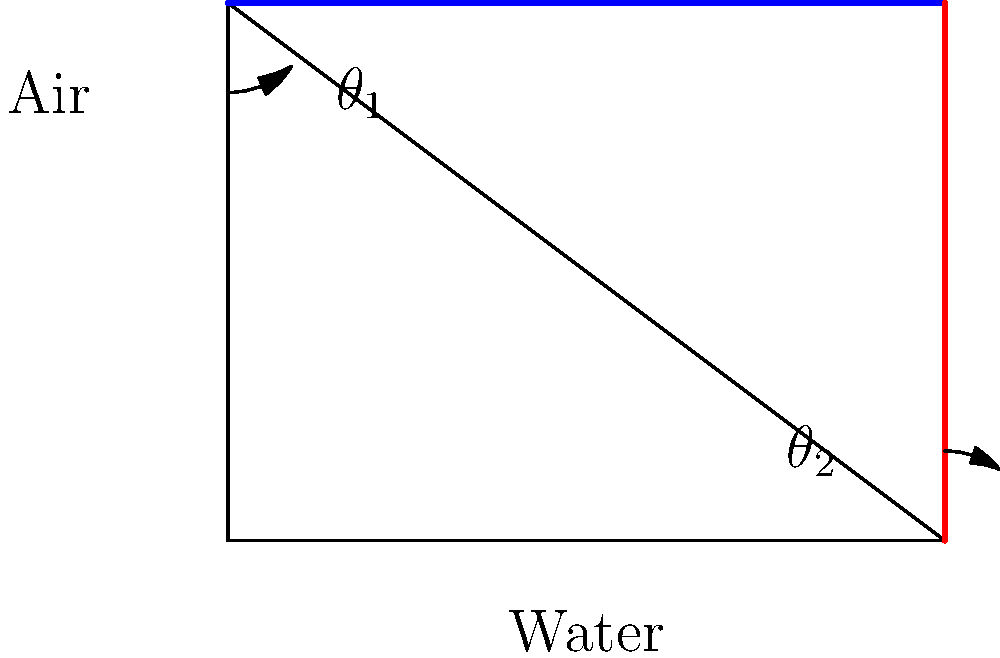In your latest novel, you've described a scene where a beam of light passes from air into water. The incident angle in air is 45°, and the speed of light in water is approximately 0.75 times its speed in air. Using Snell's law, what is the angle of refraction in water? How does this phenomenon relate to the literary concept of perspective shifting? Let's approach this step-by-step, drawing parallels to narrative perspective:

1) Snell's law states: $n_1 \sin \theta_1 = n_2 \sin \theta_2$, where $n$ is the refractive index and $\theta$ is the angle.

2) We know that $n = \frac{c}{v}$, where $c$ is the speed of light in vacuum and $v$ is the speed in the medium.

3) For air, $n_1 \approx 1$ (approximating air as vacuum).
   For water, $n_2 = \frac{1}{0.75} = \frac{4}{3}$ (since $v_{water} = 0.75c$).

4) We're given $\theta_1 = 45°$. Let's substitute into Snell's law:

   $1 \cdot \sin 45° = \frac{4}{3} \sin \theta_2$

5) Simplify: $\frac{\sqrt{2}}{2} = \frac{4}{3} \sin \theta_2$

6) Solve for $\theta_2$:
   $\sin \theta_2 = \frac{3\sqrt{2}}{8}$
   $\theta_2 = \arcsin(\frac{3\sqrt{2}}{8}) \approx 32.0°$

This refraction is analogous to how a shift in narrative perspective can alter the reader's perception of events. Just as light bends when moving between mediums, a story's interpretation can change dramatically when told from a different viewpoint, revealing hidden depths and new angles to familiar scenes.
Answer: 32.0° 